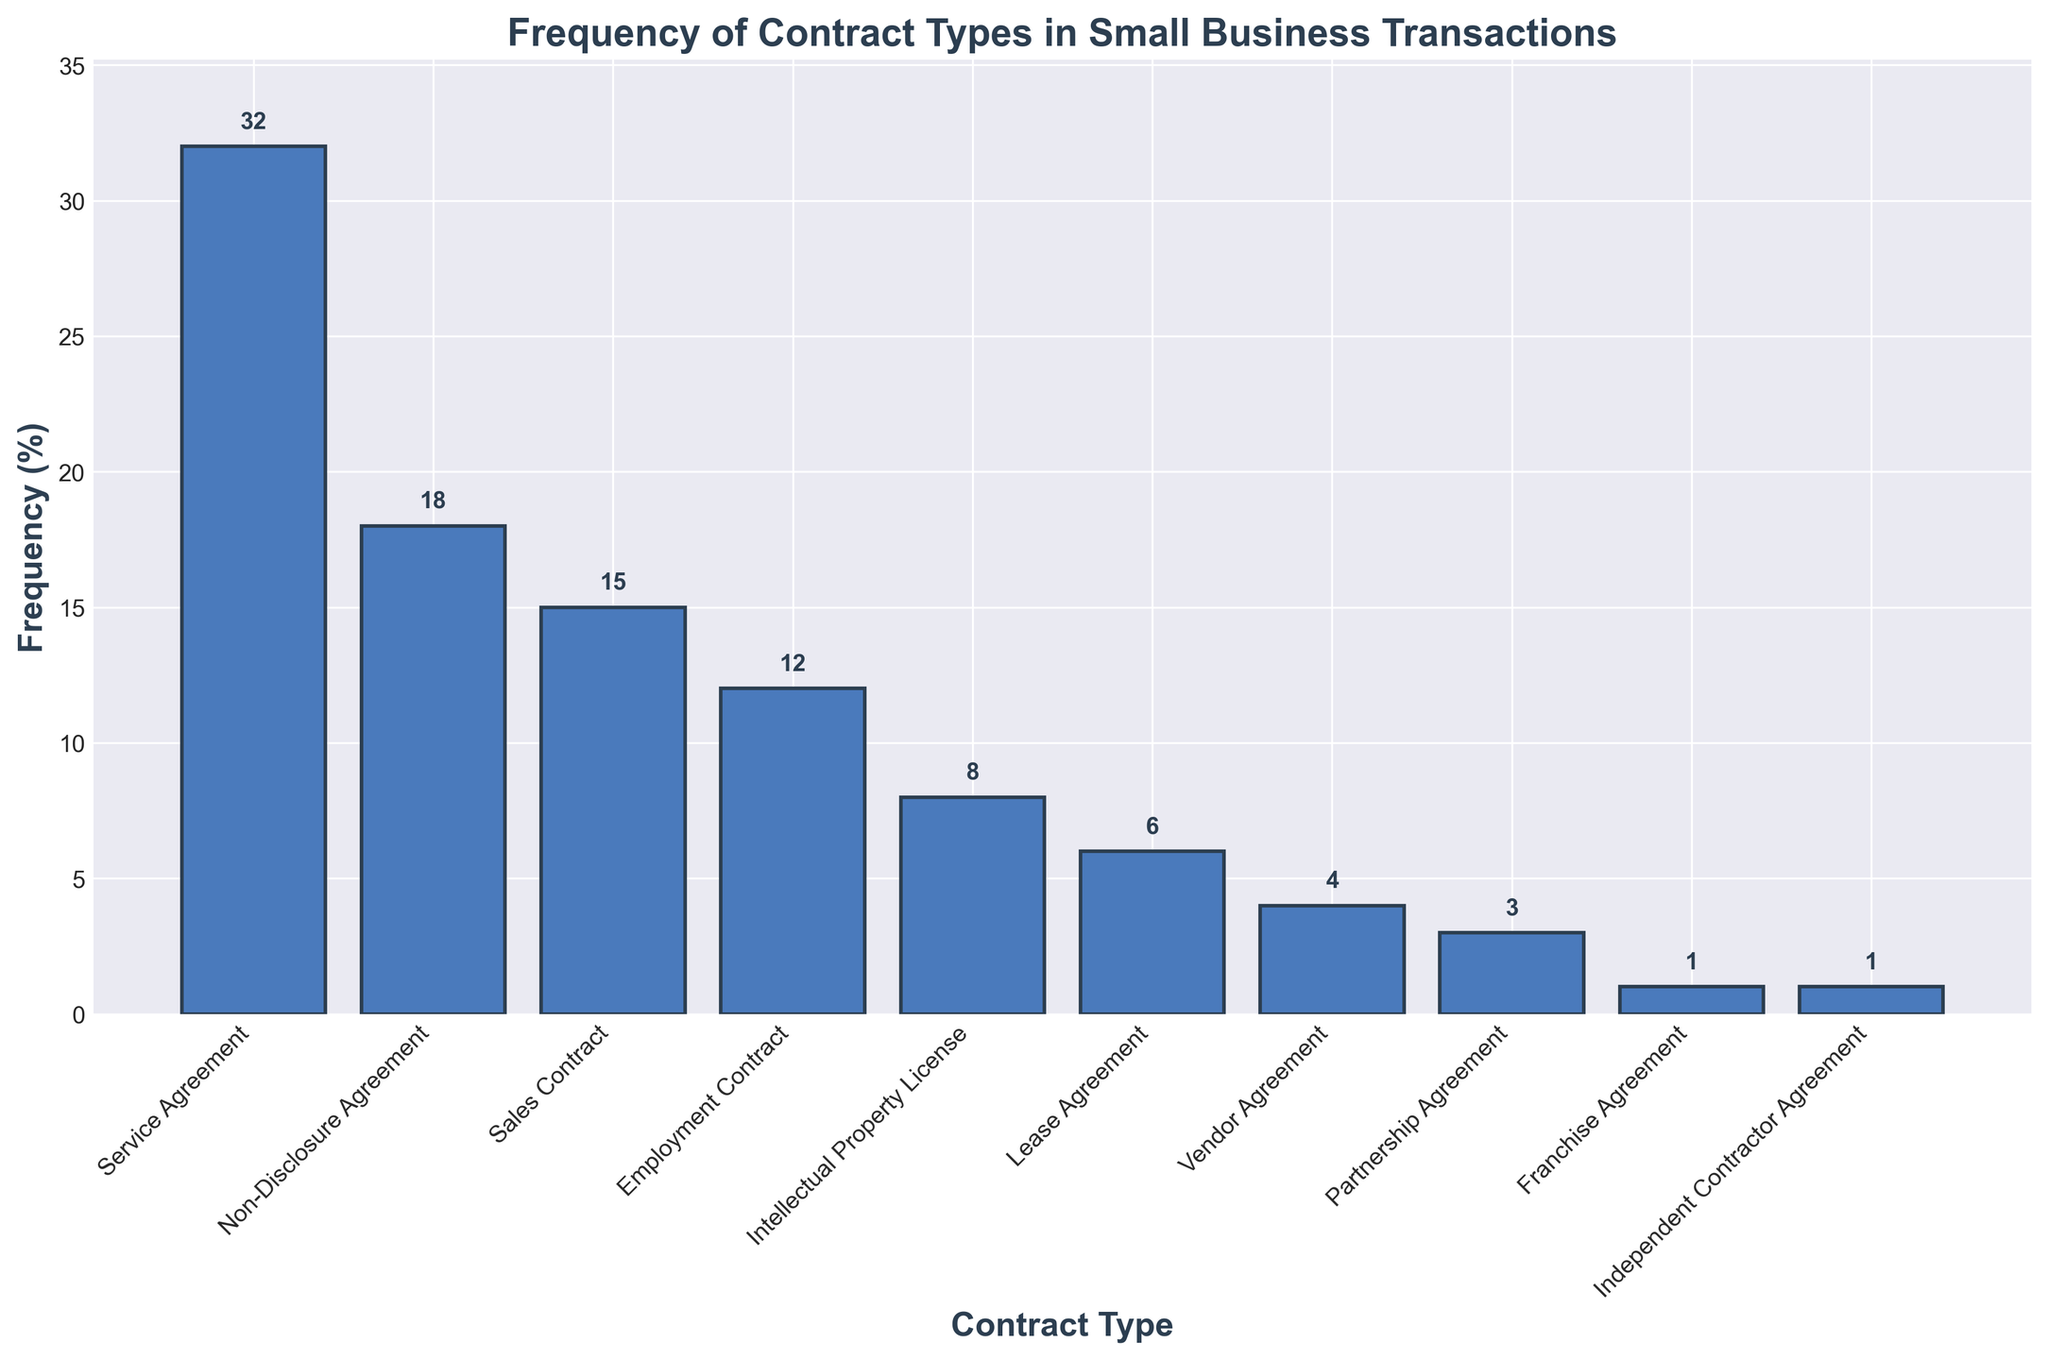What is the most frequently used contract type in small business transactions? The tallest bar in the chart represents the most frequently used contract type. The 'Service Agreement' has the highest frequency at 32%.
Answer: Service Agreement Which contract type appears least frequently in small business transactions? The shortest bars depict the least frequently used contract types. 'Franchise Agreement' and 'Independent Contractor Agreement' both have the smallest bars at 1% each.
Answer: Franchise Agreement, Independent Contractor Agreement By how much does the frequency of Service Agreements exceed that of Non-Disclosure Agreements? The frequency of Service Agreements is 32%, and that of Non-Disclosure Agreements is 18%. Subtracting the latter from the former gives 32% - 18% = 14%.
Answer: 14% What is the combined frequency of Employment and Vendor Agreements? The frequency of Employment Contracts is 12% and that of Vendor Agreements is 4%. Adding these together gives 12% + 4% = 16%.
Answer: 16% Are there more Employment Contracts or Sales Contracts used in small business transactions? By comparing the heights of the bars, Employment Contracts have a frequency of 12% while Sales Contracts have 15%. Thus, Sales Contracts are used more frequently.
Answer: Sales Contracts Which two contract types have frequencies closest to each other? Looking at the values, 'Service Agreement' (32%) and 'Non-Disclosure Agreement' (18%) have a difference of 14%, 'Sales Contract' (15%) and 'Employment Contract' (12%) have a difference of 3%, 'Intellectual Property License' (8%) and 'Lease Agreement' (6%) have a difference of 2%, 'Vendor Agreement' (4%) and 'Partnership Agreement' (3%) have a difference of 1%, 'Franchise Agreement' (1%) and 'Independent Contractor Agreement' (1%) have a difference of 0%. The closest frequencies are 'Franchise Agreement' and 'Independent Contractor Agreement' with a difference of 0%.
Answer: Franchise Agreement, Independent Contractor Agreement Between Sales Contracts and Lease Agreements, which one is more frequently used, and by how much? Sales Contracts have a frequency of 15%, and Lease Agreements have a frequency of 6%. Subtracting the latter from the former, 15% - 6% = 9%. Sales Contracts are more frequently used by 9%.
Answer: Sales Contracts by 9% What proportion of the total frequency is contributed by the top three most frequent contract types? The frequencies of the top three contract types are Service Agreement (32%), Non-Disclosure Agreement (18%), and Sales Contract (15%). Adding them gives 32% + 18% + 15% = 65%. The top three contribute 65% to the total frequency.
Answer: 65% 